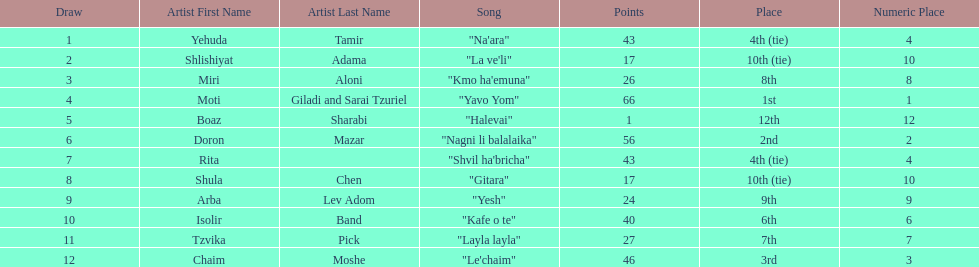How many points does the artist rita have? 43. I'm looking to parse the entire table for insights. Could you assist me with that? {'header': ['Draw', 'Artist First Name', 'Artist Last Name', 'Song', 'Points', 'Place', 'Numeric Place'], 'rows': [['1', 'Yehuda', 'Tamir', '"Na\'ara"', '43', '4th (tie)', '4'], ['2', 'Shlishiyat', 'Adama', '"La ve\'li"', '17', '10th (tie)', '10'], ['3', 'Miri', 'Aloni', '"Kmo ha\'emuna"', '26', '8th', '8'], ['4', 'Moti', 'Giladi and Sarai Tzuriel', '"Yavo Yom"', '66', '1st', '1'], ['5', 'Boaz', 'Sharabi', '"Halevai"', '1', '12th', '12'], ['6', 'Doron', 'Mazar', '"Nagni li balalaika"', '56', '2nd', '2'], ['7', 'Rita', '', '"Shvil ha\'bricha"', '43', '4th (tie)', '4'], ['8', 'Shula', 'Chen', '"Gitara"', '17', '10th (tie)', '10'], ['9', 'Arba', 'Lev Adom', '"Yesh"', '24', '9th', '9'], ['10', 'Isolir', 'Band', '"Kafe o te"', '40', '6th', '6'], ['11', 'Tzvika', 'Pick', '"Layla layla"', '27', '7th', '7'], ['12', 'Chaim', 'Moshe', '"Le\'chaim"', '46', '3rd', '3']]} 